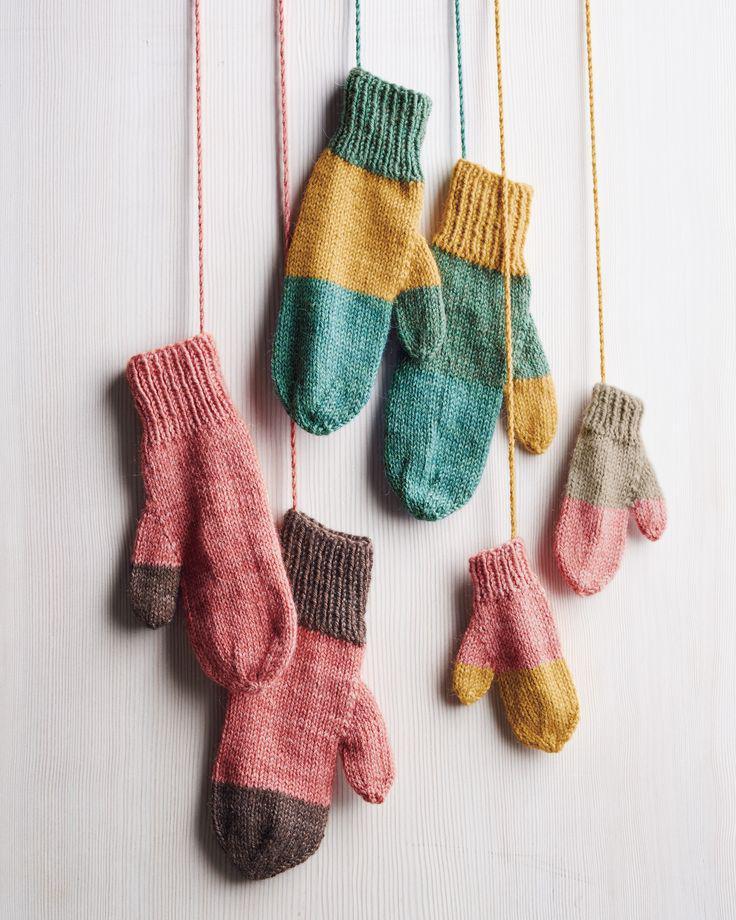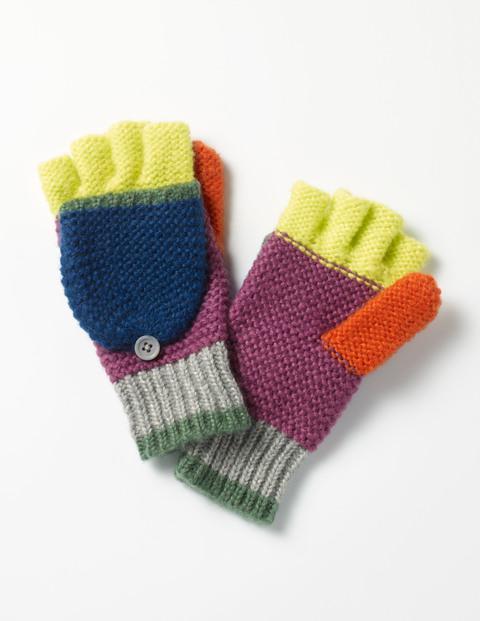The first image is the image on the left, the second image is the image on the right. Considering the images on both sides, is "An image shows some type of needle inserted into the yarn of a mitten." valid? Answer yes or no. No. The first image is the image on the left, the second image is the image on the right. Considering the images on both sides, is "There is a pair of mittens and one is in the process of being knitted." valid? Answer yes or no. No. 